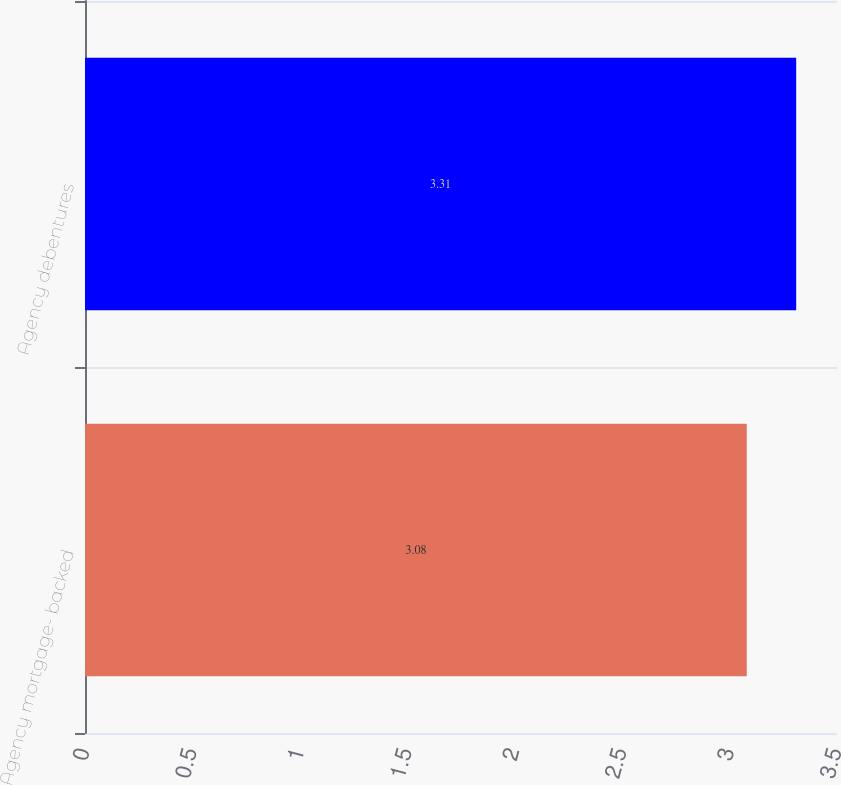Convert chart to OTSL. <chart><loc_0><loc_0><loc_500><loc_500><bar_chart><fcel>Agency mortgage- backed<fcel>Agency debentures<nl><fcel>3.08<fcel>3.31<nl></chart> 